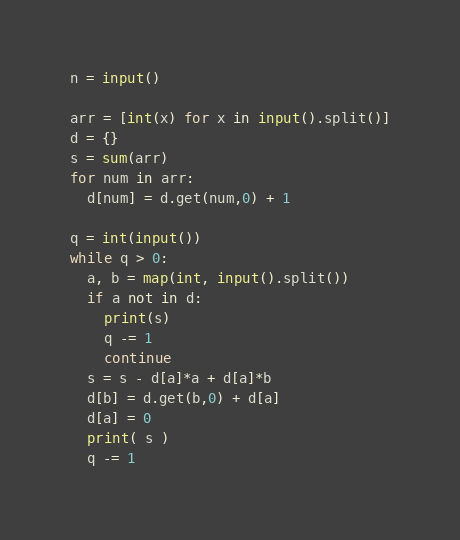<code> <loc_0><loc_0><loc_500><loc_500><_Python_>n = input()

arr = [int(x) for x in input().split()]
d = {}
s = sum(arr)
for num in arr:
  d[num] = d.get(num,0) + 1
  
q = int(input())
while q > 0:
  a, b = map(int, input().split())
  if a not in d:
    print(s)
    q -= 1
    continue
  s = s - d[a]*a + d[a]*b
  d[b] = d.get(b,0) + d[a]
  d[a] = 0
  print( s )
  q -= 1</code> 